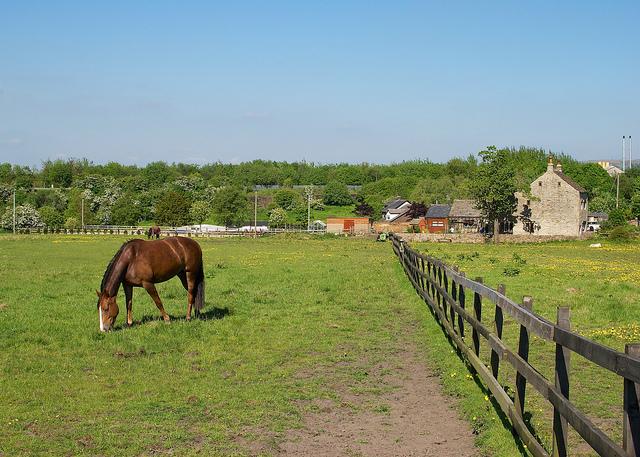Does this photo look like a countryside?
Give a very brief answer. Yes. Was this picture taken in January?
Write a very short answer. No. What is the horse doing?
Keep it brief. Grazing. What animal is in the image?
Keep it brief. Horse. 